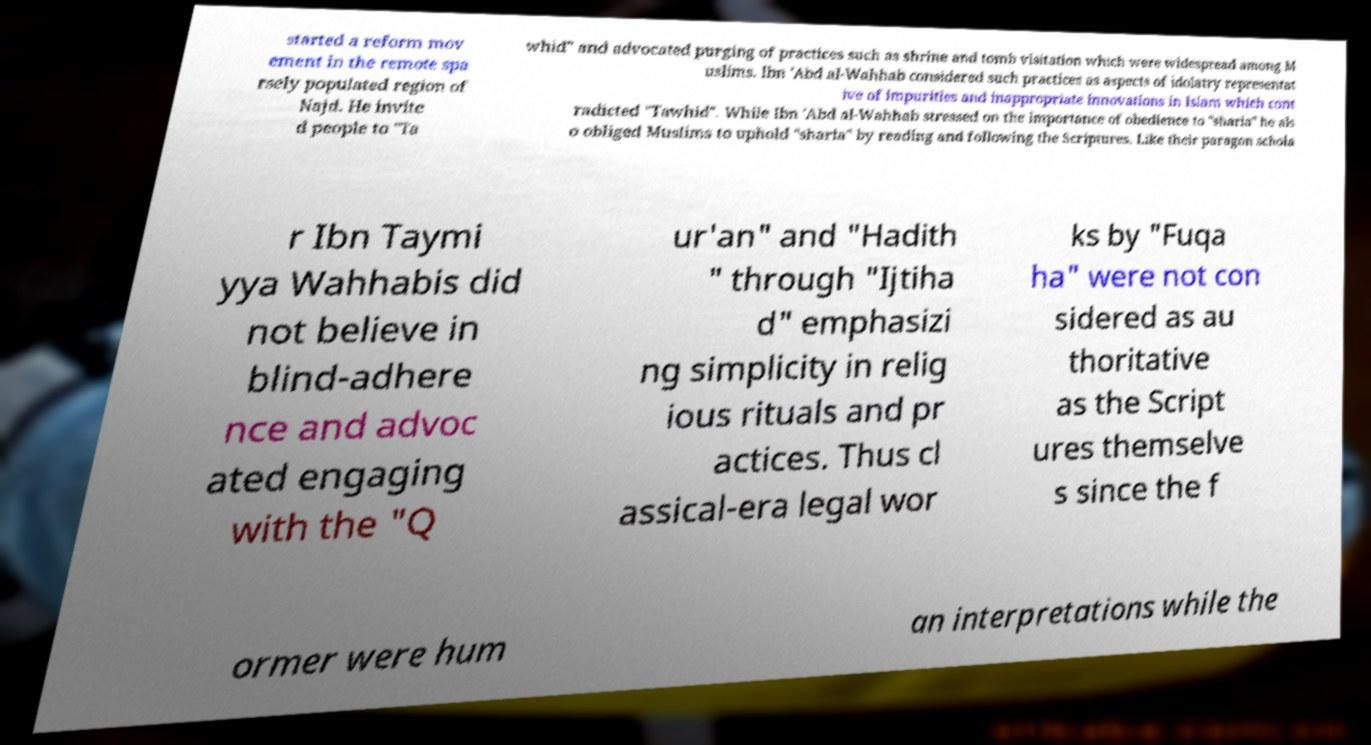Please read and relay the text visible in this image. What does it say? started a reform mov ement in the remote spa rsely populated region of Najd. He invite d people to "Ta whid" and advocated purging of practices such as shrine and tomb visitation which were widespread among M uslims. Ibn 'Abd al-Wahhab considered such practices as aspects of idolatry representat ive of impurities and inappropriate innovations in Islam which cont radicted "Tawhid". While Ibn 'Abd al-Wahhab stressed on the importance of obedience to "sharia" he als o obliged Muslims to uphold "sharia" by reading and following the Scriptures. Like their paragon schola r Ibn Taymi yya Wahhabis did not believe in blind-adhere nce and advoc ated engaging with the "Q ur'an" and "Hadith " through "Ijtiha d" emphasizi ng simplicity in relig ious rituals and pr actices. Thus cl assical-era legal wor ks by "Fuqa ha" were not con sidered as au thoritative as the Script ures themselve s since the f ormer were hum an interpretations while the 